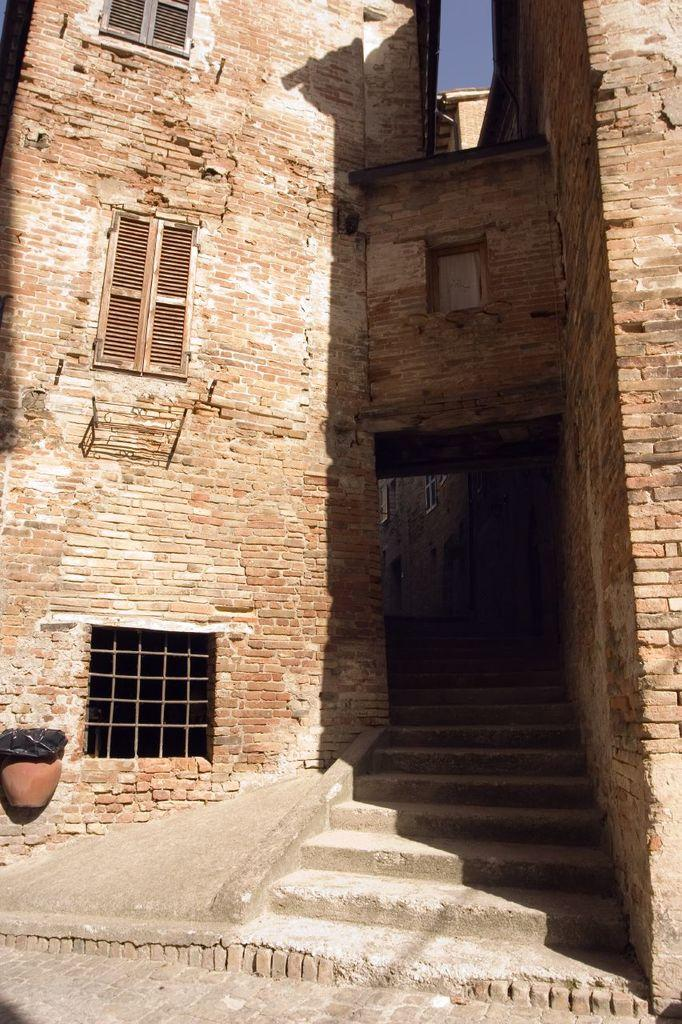What type of structure is visible in the image? There is a building in the image. What feature can be seen on the building? The building has windows. What is the other object visible in the image? There is a pot in the image. Can you describe the color of any object in the image? There is an object of black color in the image. What type of education is being taught in the building in the image? There is no indication of education or any teaching activities taking place in the building in the image. 